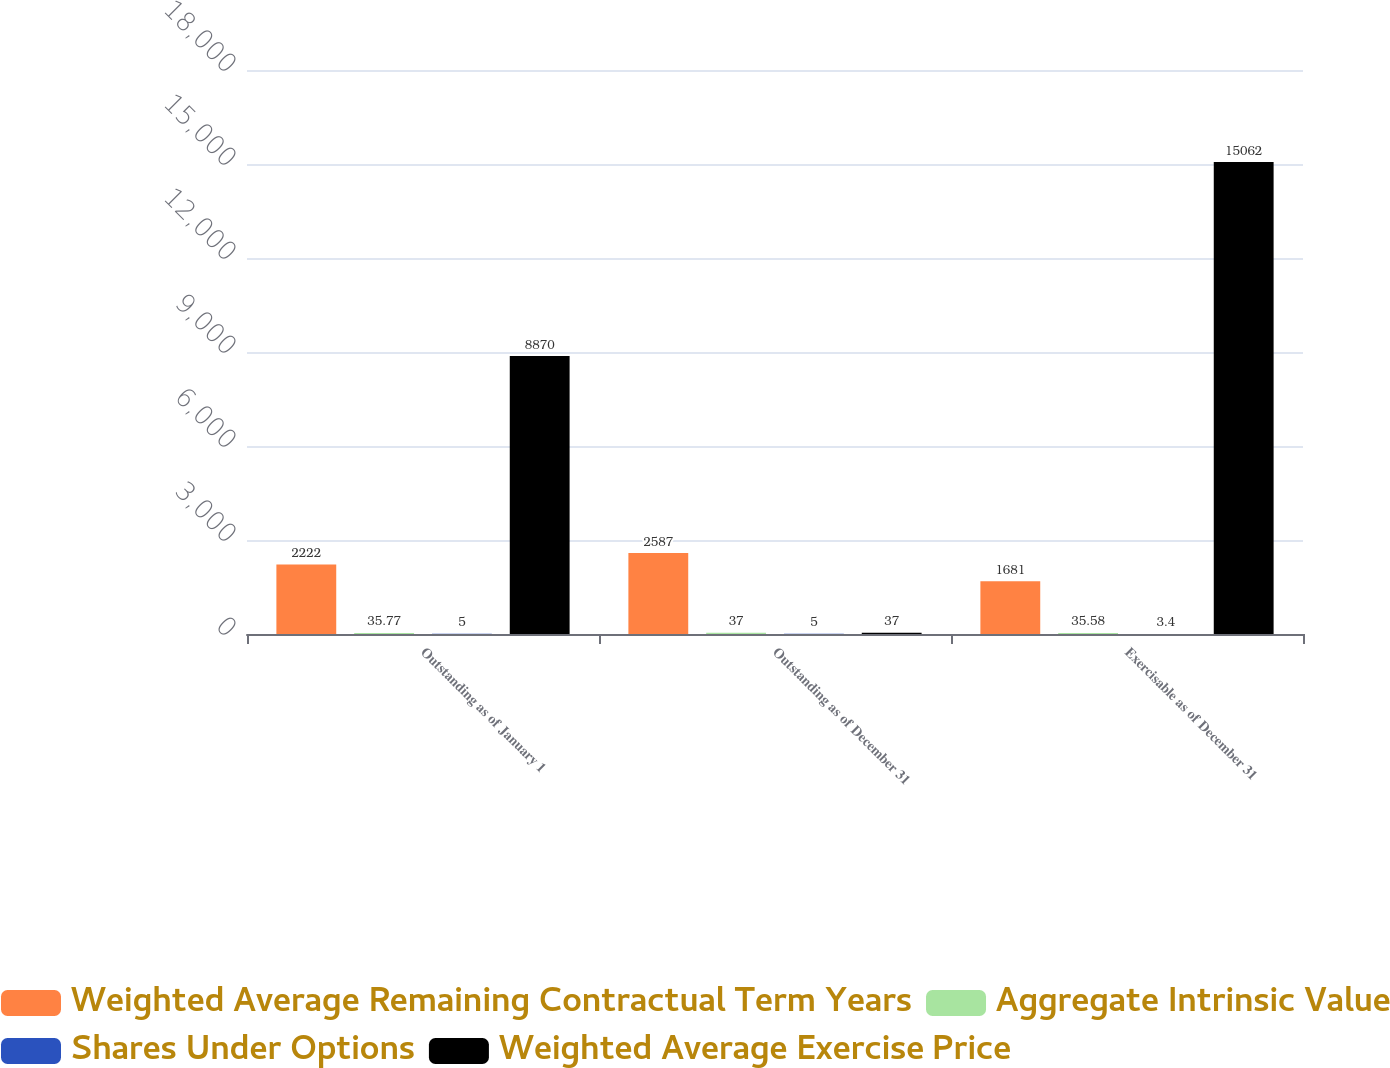Convert chart. <chart><loc_0><loc_0><loc_500><loc_500><stacked_bar_chart><ecel><fcel>Outstanding as of January 1<fcel>Outstanding as of December 31<fcel>Exercisable as of December 31<nl><fcel>Weighted Average Remaining Contractual Term Years<fcel>2222<fcel>2587<fcel>1681<nl><fcel>Aggregate Intrinsic Value<fcel>35.77<fcel>37<fcel>35.58<nl><fcel>Shares Under Options<fcel>5<fcel>5<fcel>3.4<nl><fcel>Weighted Average Exercise Price<fcel>8870<fcel>37<fcel>15062<nl></chart> 